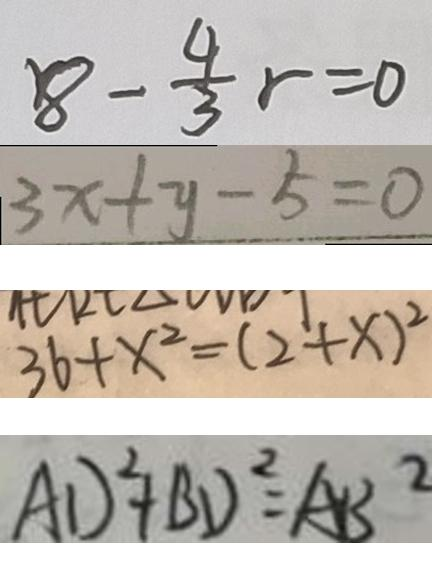<formula> <loc_0><loc_0><loc_500><loc_500>8 - \frac { 4 } { 3 } r = 0 
 3 x + y - 5 = 0 
 3 6 + x ^ { 2 } = ( 2 + x ) ^ { 2 } 
 A D ^ { 2 } + B D ^ { 2 } = A B ^ { 2 }</formula> 